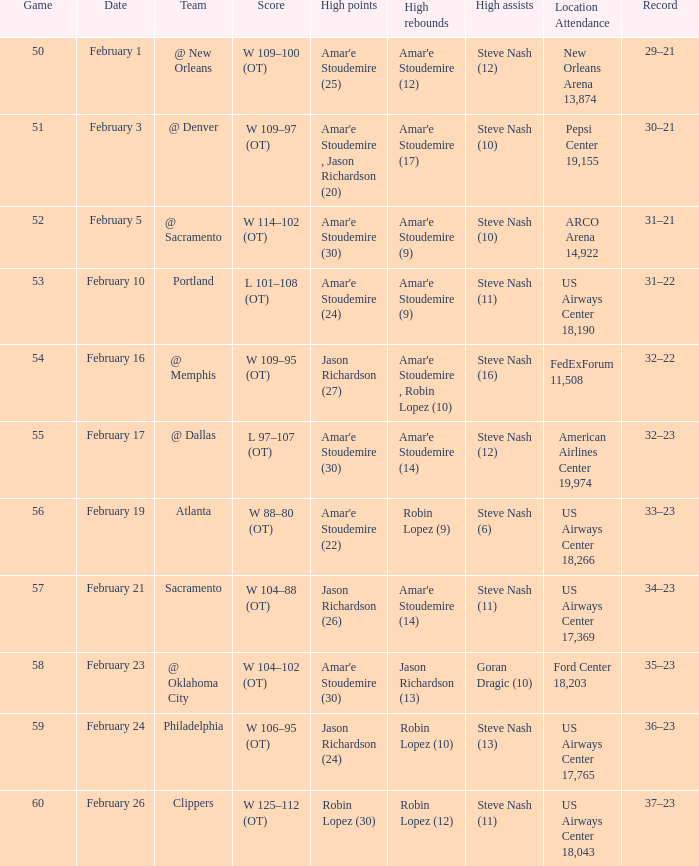Name the date for score w 109–95 (ot) February 16. 